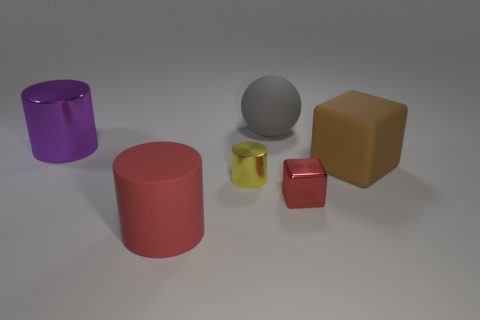Are there any other things that have the same shape as the gray matte thing?
Keep it short and to the point. No. What material is the big cylinder that is in front of the shiny thing behind the big object that is to the right of the gray ball?
Your answer should be compact. Rubber. Are there an equal number of big matte things that are in front of the red shiny object and large metal cylinders?
Your answer should be very brief. Yes. How many objects are large cyan shiny balls or yellow shiny cylinders?
Provide a succinct answer. 1. There is a small yellow thing that is made of the same material as the purple object; what shape is it?
Give a very brief answer. Cylinder. There is a metal cylinder that is to the right of the purple shiny thing left of the tiny red metal object; what is its size?
Provide a short and direct response. Small. What number of large things are balls or green rubber balls?
Provide a short and direct response. 1. What number of other objects are there of the same color as the large matte cylinder?
Keep it short and to the point. 1. There is a cylinder that is behind the large brown matte object; does it have the same size as the matte thing left of the ball?
Your response must be concise. Yes. Is the gray ball made of the same material as the tiny cylinder behind the red rubber cylinder?
Your response must be concise. No. 